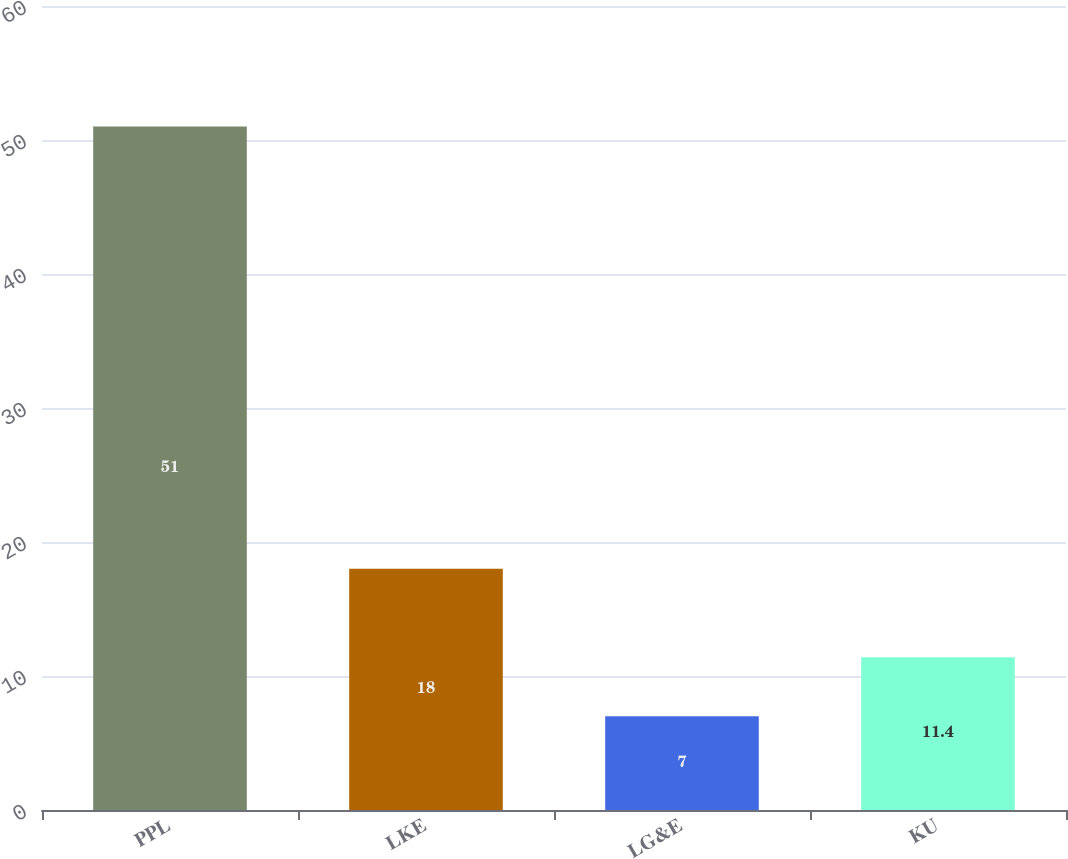Convert chart to OTSL. <chart><loc_0><loc_0><loc_500><loc_500><bar_chart><fcel>PPL<fcel>LKE<fcel>LG&E<fcel>KU<nl><fcel>51<fcel>18<fcel>7<fcel>11.4<nl></chart> 